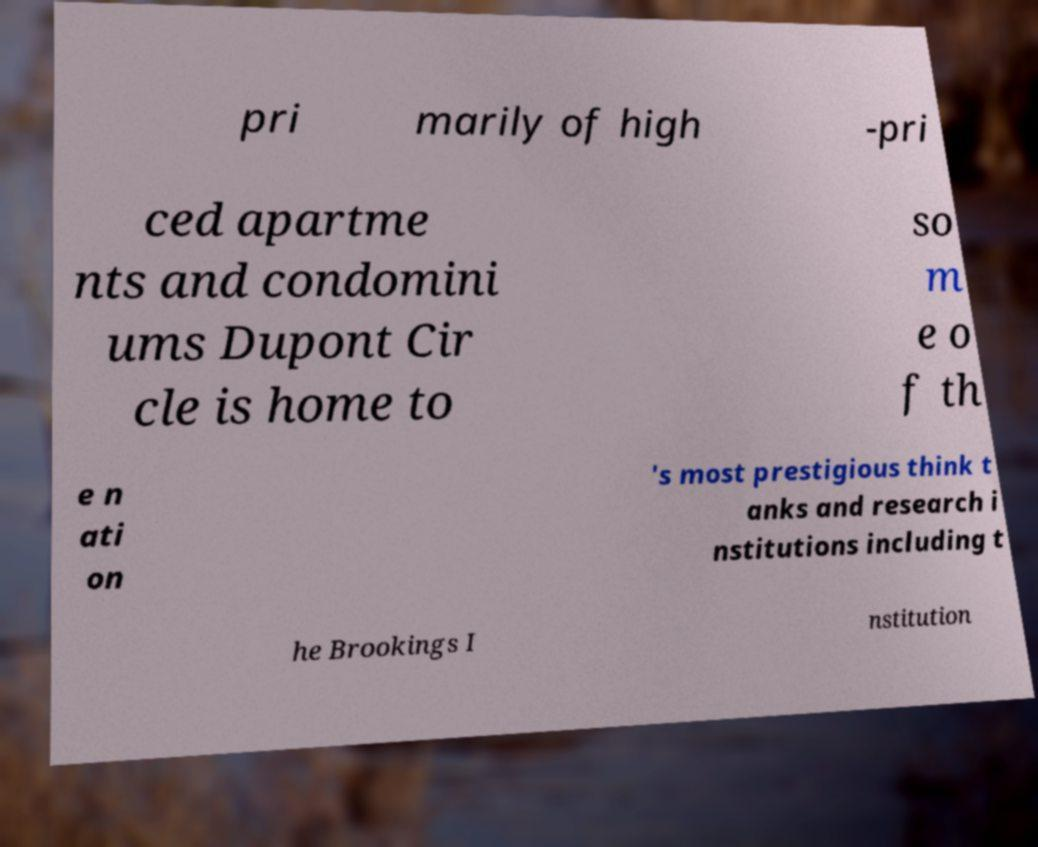Could you extract and type out the text from this image? pri marily of high -pri ced apartme nts and condomini ums Dupont Cir cle is home to so m e o f th e n ati on 's most prestigious think t anks and research i nstitutions including t he Brookings I nstitution 